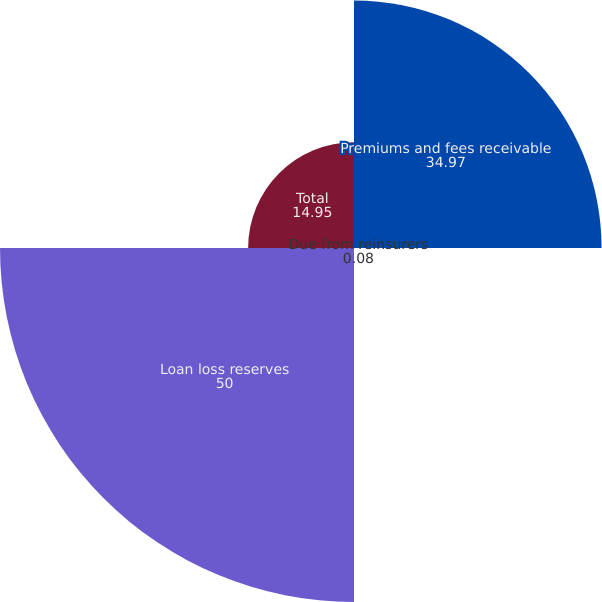Convert chart. <chart><loc_0><loc_0><loc_500><loc_500><pie_chart><fcel>Premiums and fees receivable<fcel>Due from reinsurers<fcel>Loan loss reserves<fcel>Total<nl><fcel>34.97%<fcel>0.08%<fcel>50.0%<fcel>14.95%<nl></chart> 